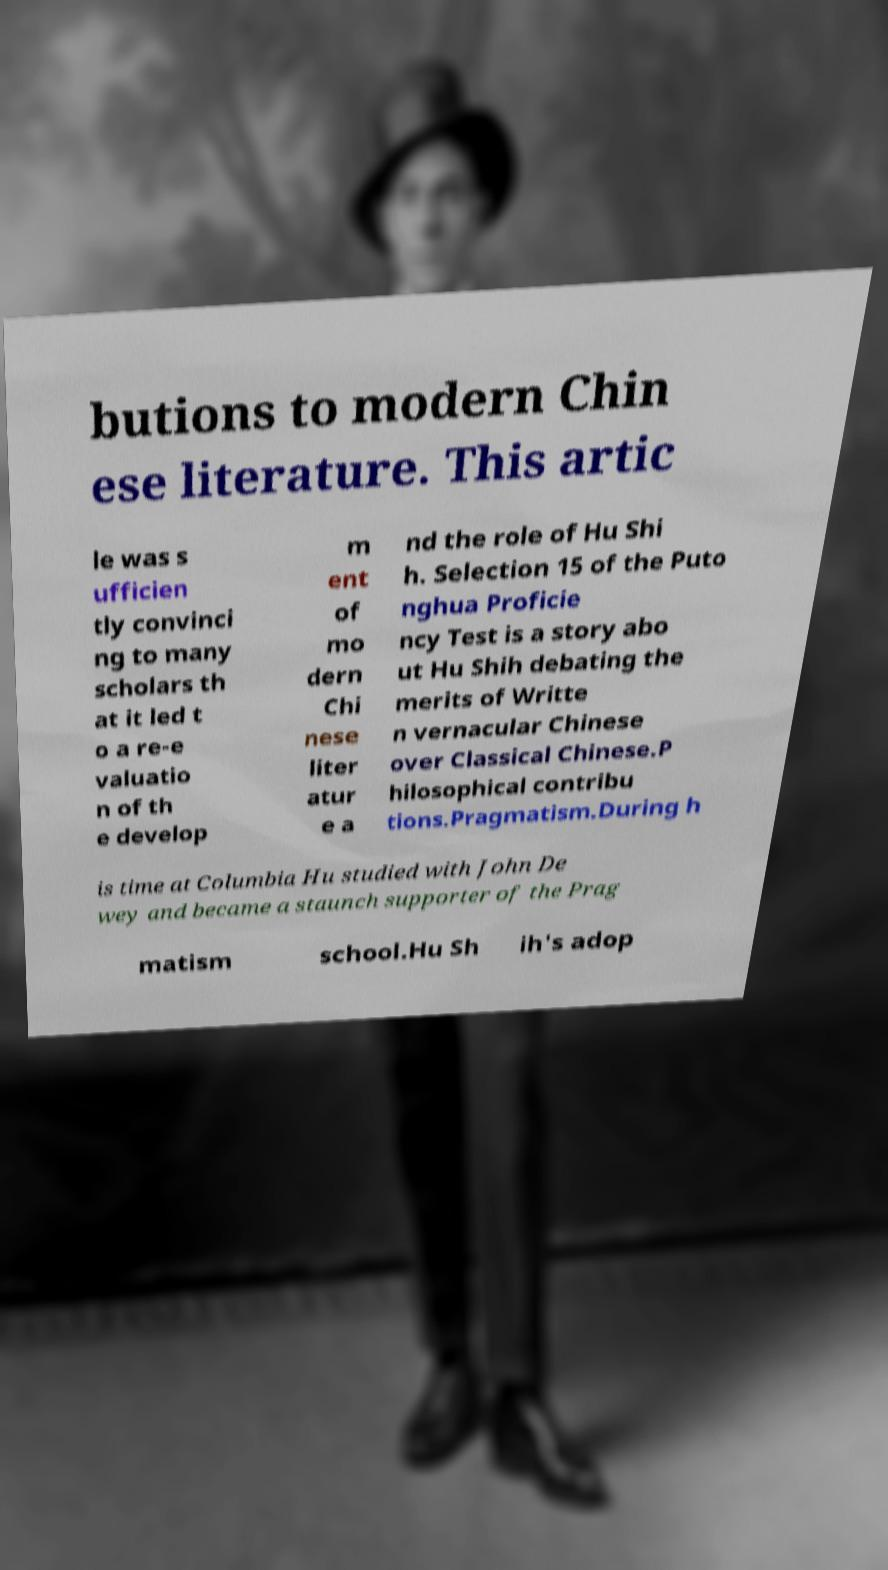Can you accurately transcribe the text from the provided image for me? butions to modern Chin ese literature. This artic le was s ufficien tly convinci ng to many scholars th at it led t o a re-e valuatio n of th e develop m ent of mo dern Chi nese liter atur e a nd the role of Hu Shi h. Selection 15 of the Puto nghua Proficie ncy Test is a story abo ut Hu Shih debating the merits of Writte n vernacular Chinese over Classical Chinese.P hilosophical contribu tions.Pragmatism.During h is time at Columbia Hu studied with John De wey and became a staunch supporter of the Prag matism school.Hu Sh ih's adop 